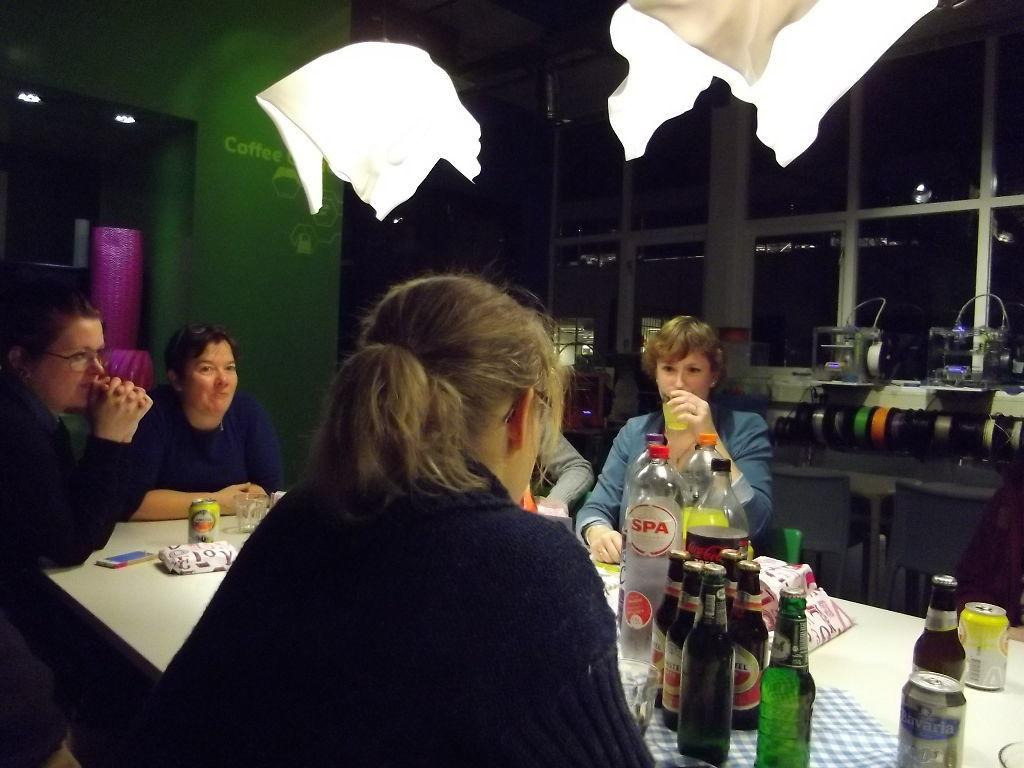How many people are in the image? There is a group of people in the image. What are the people doing in the image? The people are sitting in chairs. What is on the table in the image? There are bottles and a mobile phone on the table. What can be seen in the background of the image? There are lights and engines in the background of the image. What type of feast is being prepared on the table in the image? There is no feast being prepared on the table in the image; it only contains bottles and a mobile phone. What type of seat is the person in the image using to read their book? There is no person reading a book in the image, and no specific type of seat is mentioned. 